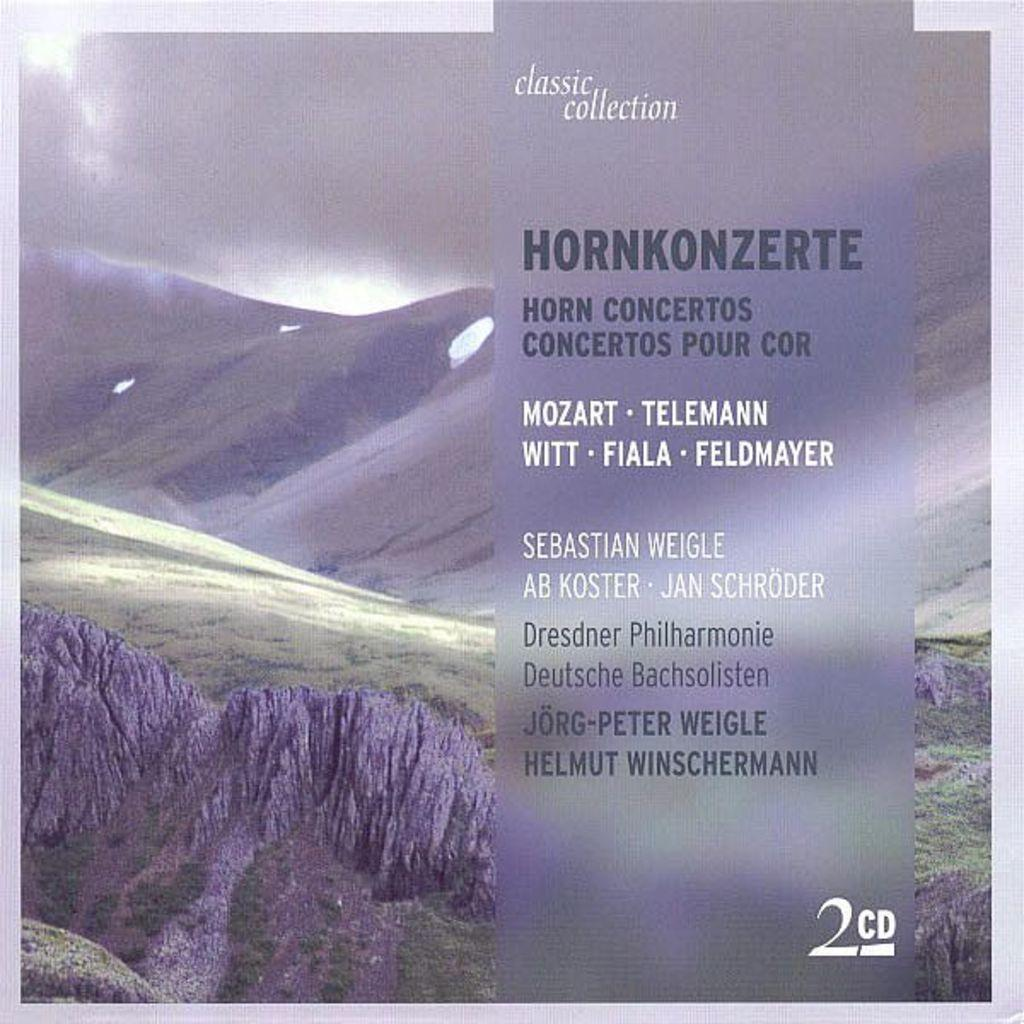What is located on the right side of the poster in the foreground? There is text on the right side of the poster in the foreground. What type of landscape can be seen in the background of the poster? There is grassland and mountains in the background of the poster. What is visible in the sky in the background of the poster? The sky is visible in the background of the poster, and there is a cloud in the sky. How many children are playing in the grassland in the morning in the image? There are no children present in the image, and the time of day is not specified. 